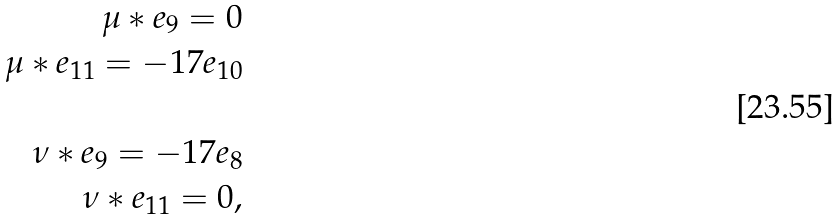Convert formula to latex. <formula><loc_0><loc_0><loc_500><loc_500>\mu * e _ { 9 } = 0 \\ \mu * e _ { 1 1 } = - 1 7 e _ { 1 0 } \\ \\ \nu * e _ { 9 } = - 1 7 e _ { 8 } \\ \nu * e _ { 1 1 } = 0 ,</formula> 